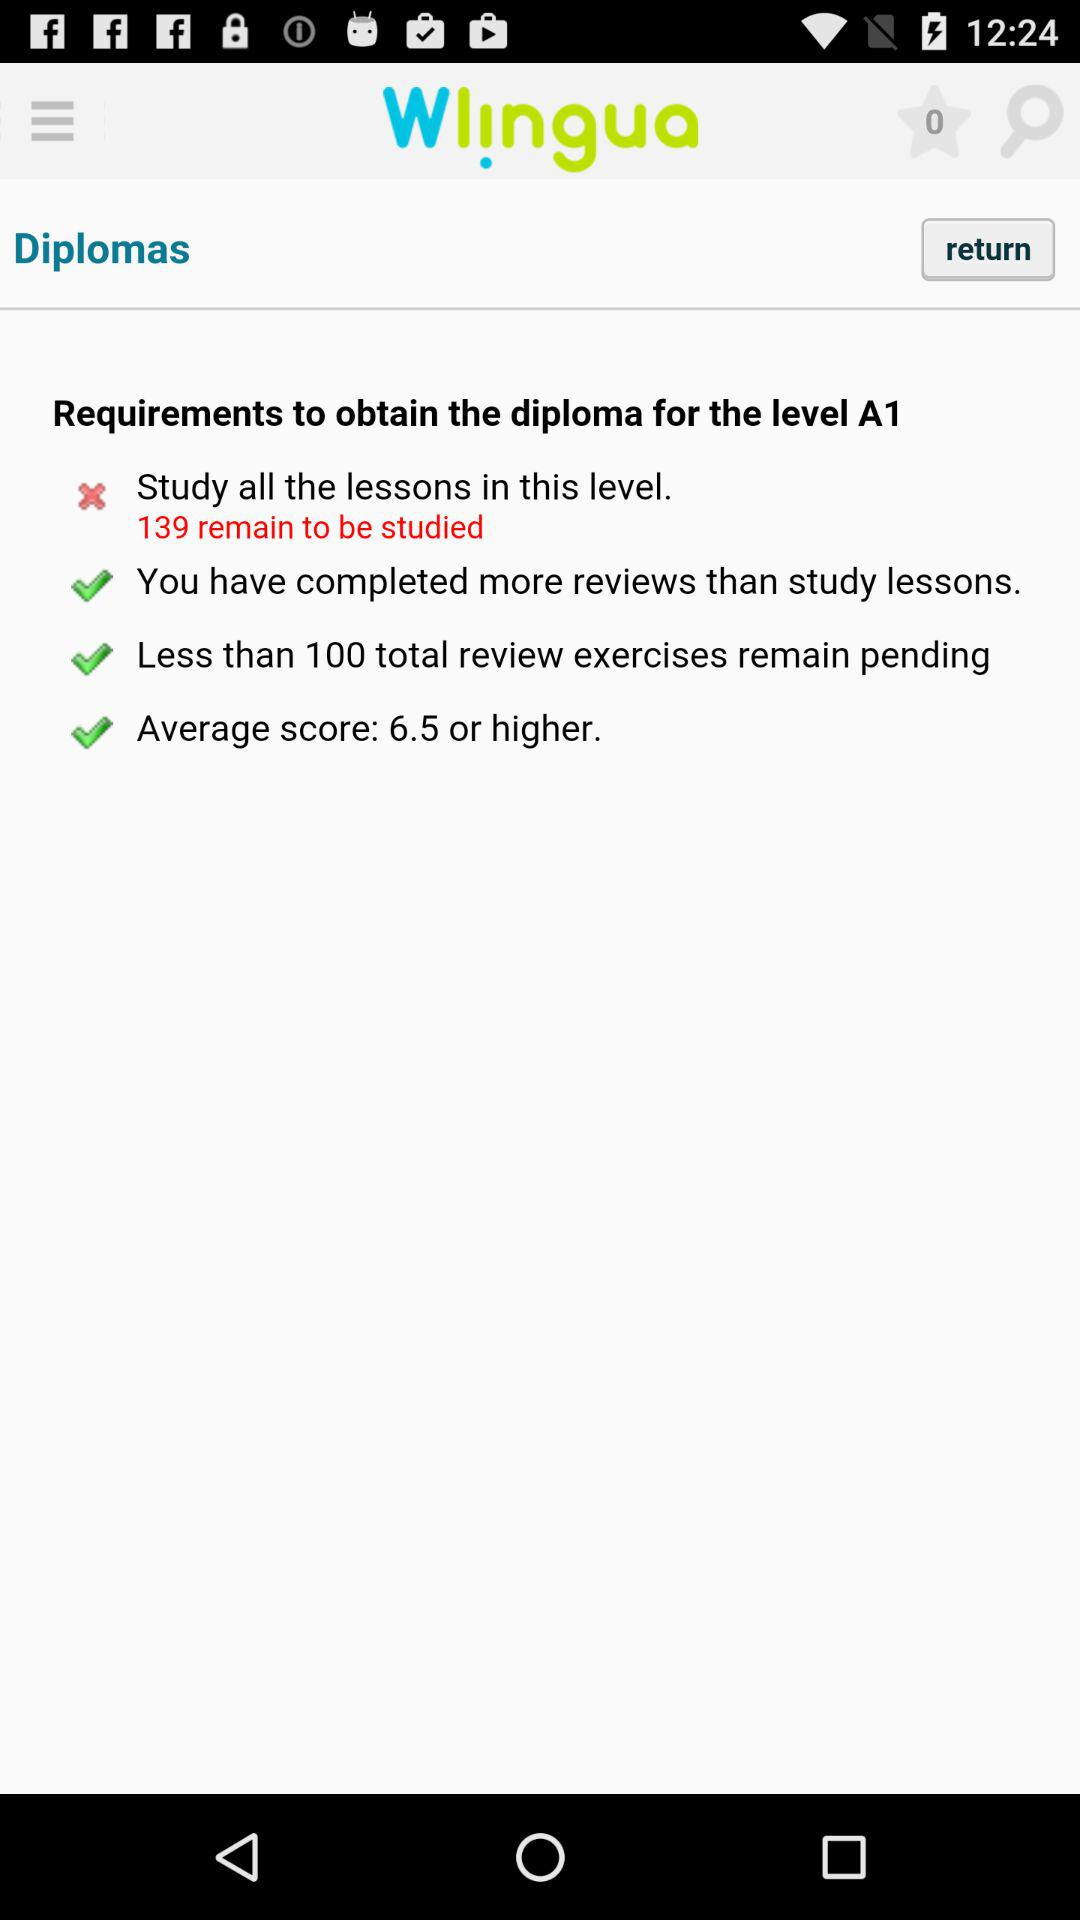What is the number of lessons that remain to be studied? There are 139 lessons that remain to be studied. 